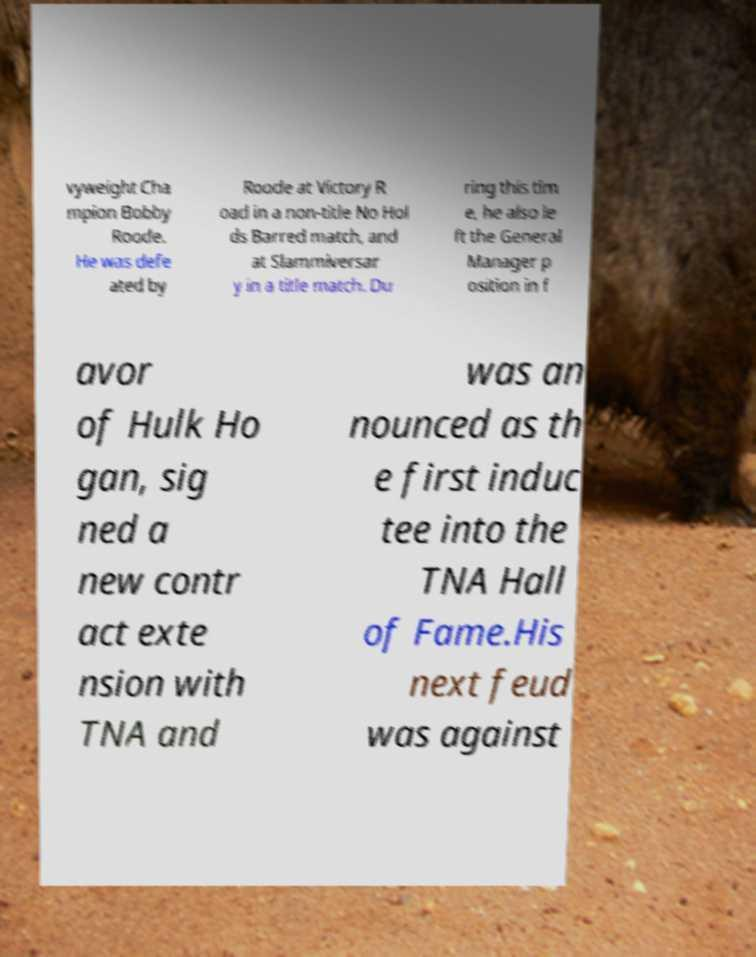Could you assist in decoding the text presented in this image and type it out clearly? vyweight Cha mpion Bobby Roode. He was defe ated by Roode at Victory R oad in a non-title No Hol ds Barred match, and at Slammiversar y in a title match. Du ring this tim e, he also le ft the General Manager p osition in f avor of Hulk Ho gan, sig ned a new contr act exte nsion with TNA and was an nounced as th e first induc tee into the TNA Hall of Fame.His next feud was against 